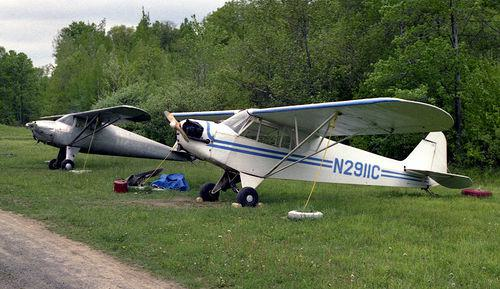Can you infer what time of year it might be in this image? Given the greenery of the grass and trees, as well as the lack of snow or autumnal leaf colors, it could be inferred that the photo was taken during spring or summer. 